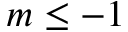<formula> <loc_0><loc_0><loc_500><loc_500>m \leq - 1</formula> 